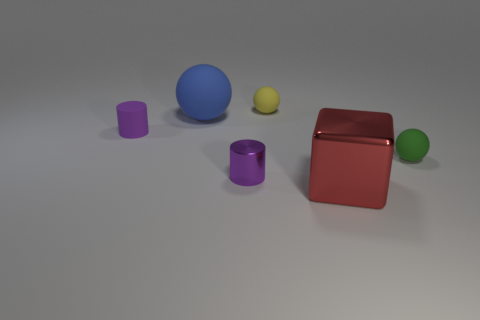Add 2 small green things. How many objects exist? 8 Subtract all cylinders. How many objects are left? 4 Subtract all small purple rubber cubes. Subtract all tiny yellow things. How many objects are left? 5 Add 2 large red things. How many large red things are left? 3 Add 5 small shiny cylinders. How many small shiny cylinders exist? 6 Subtract 0 blue cubes. How many objects are left? 6 